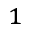Convert formula to latex. <formula><loc_0><loc_0><loc_500><loc_500>_ { 1 }</formula> 